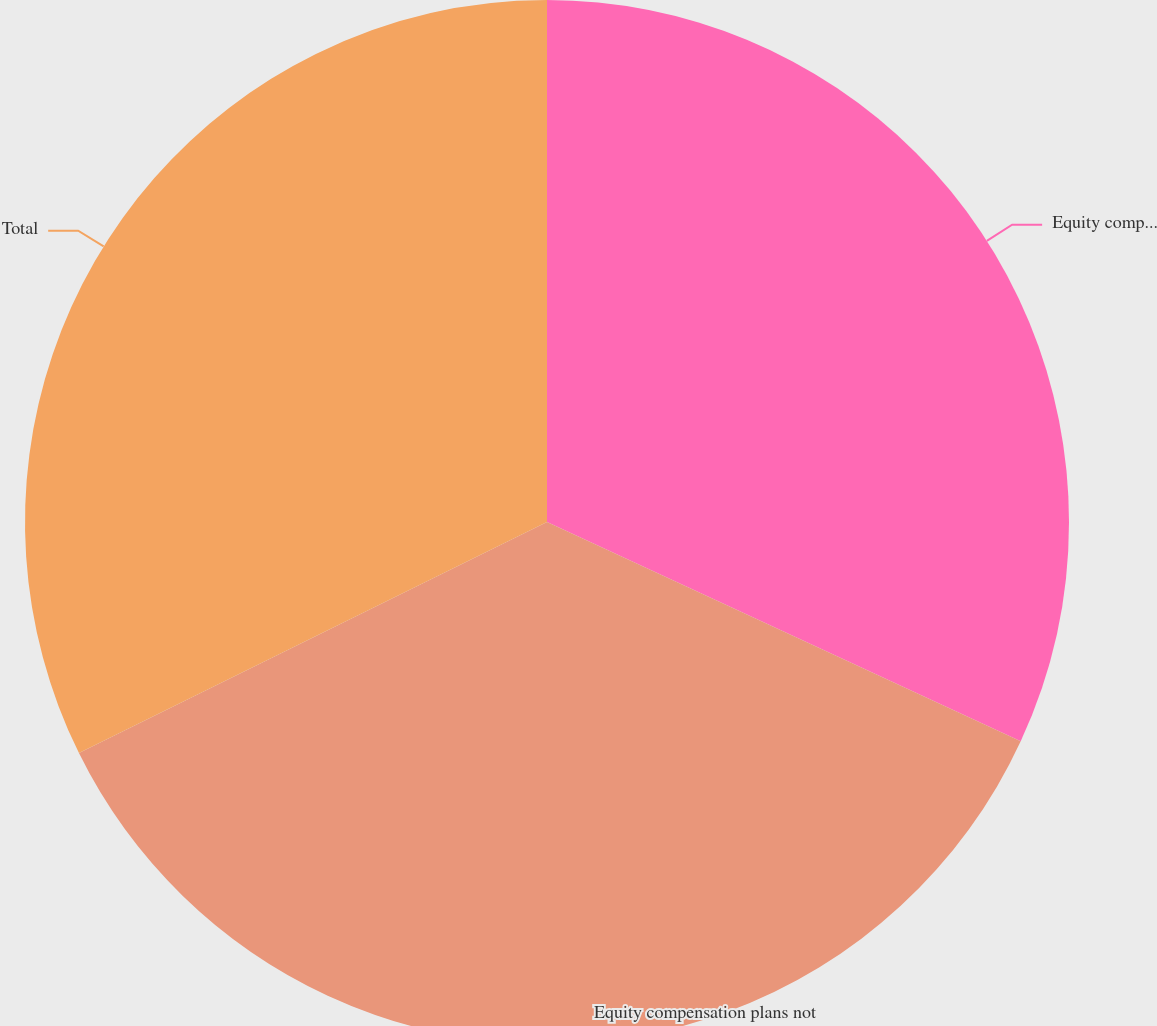<chart> <loc_0><loc_0><loc_500><loc_500><pie_chart><fcel>Equity compensation plans<fcel>Equity compensation plans not<fcel>Total<nl><fcel>31.9%<fcel>35.8%<fcel>32.3%<nl></chart> 